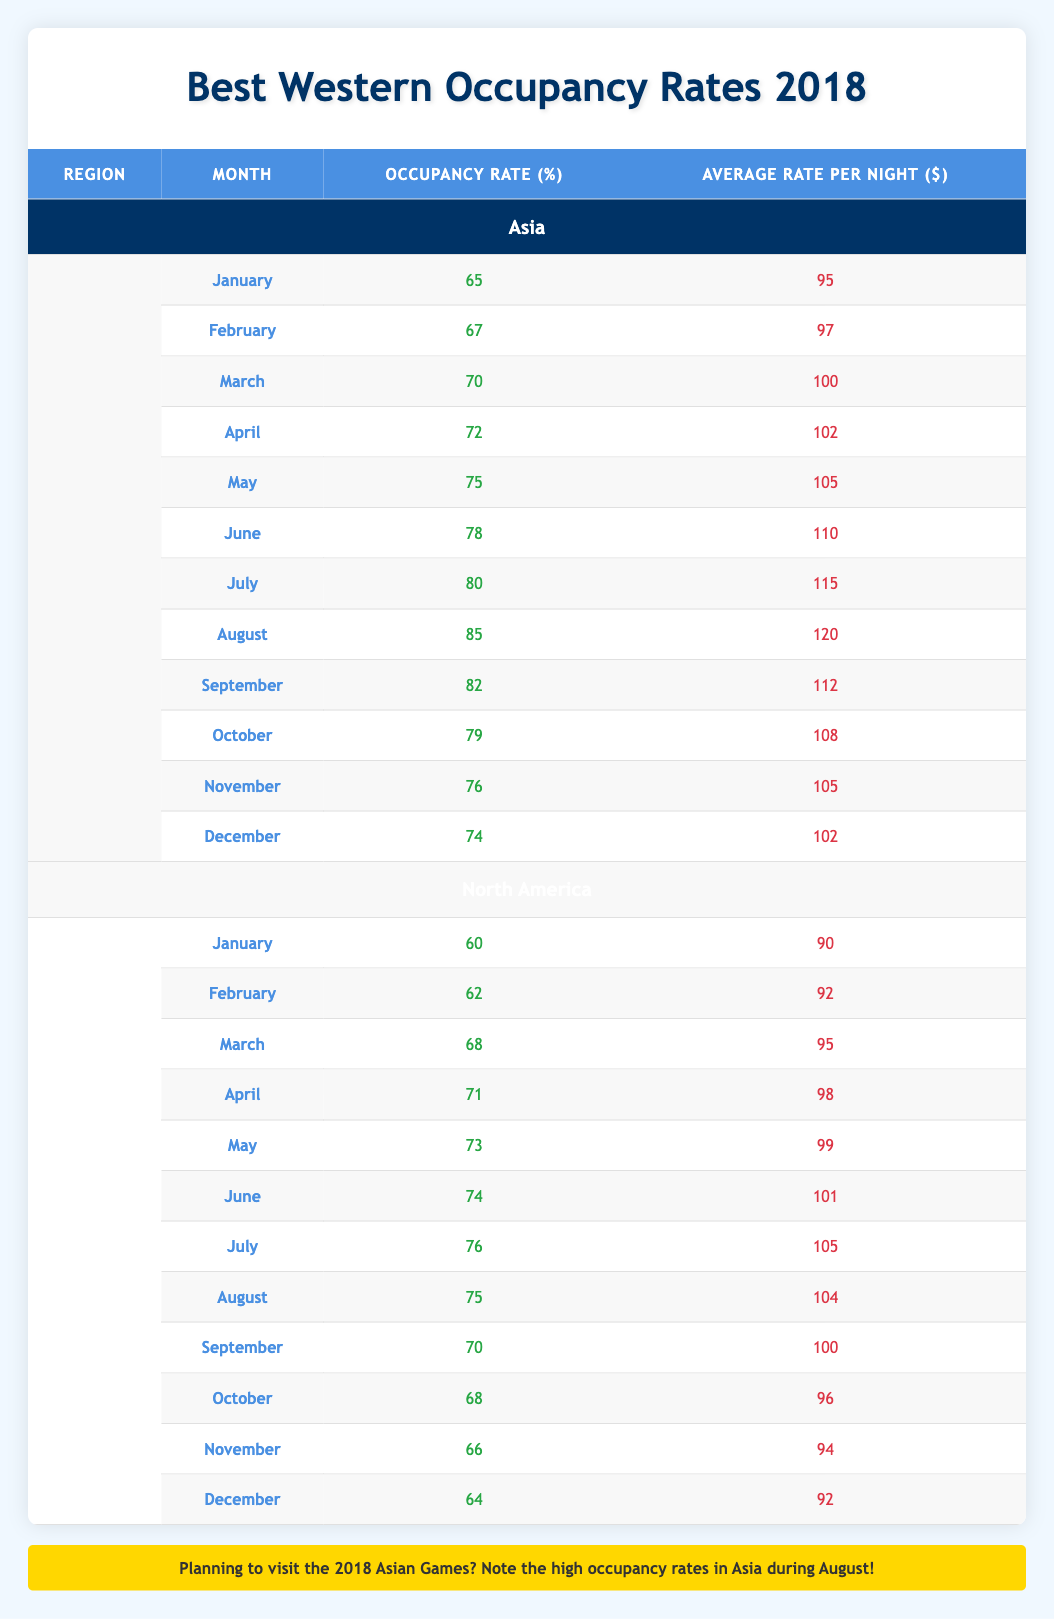What was the highest occupancy rate in Asia during 2018? The table shows monthly occupancy rates for Asia in each month of 2018. Scanning through these rates, August has the highest occupancy rate listed at 85%.
Answer: 85 What was the average occupancy rate for North America in the first half of 2018? The occupancy rates for North America from January to June are (60, 62, 68, 71, 73, 74). To find the average, add these values: 60 + 62 + 68 + 71 + 73 + 74 = 408. Then divide by 6 (the number of months): 408 / 6 = 68.
Answer: 68 Did North America have a higher occupancy rate than Asia in March 2018? The occupancy rate for Asia in March is 70, while for North America it is 68. Since 70 is greater than 68, the answer is yes.
Answer: Yes What was the difference in average rates per night between the highest month in Asia and the highest month in North America? In Asia, the highest average rate per night is 120 in August, and in North America, it is 105 in July. The difference is: 120 - 105 = 15.
Answer: 15 What was the occupancy rate trend in Asia from January to August 2018? The occupancy rates for Asia from January to August are: 65, 67, 70, 72, 75, 78, 80, and 85. Observing these values, there is an increasing trend each month leading up to August, where the highest occupancy rate occurs.
Answer: Increasing trend Which month had the lowest average rate per night in North America? The table indicates North America's average rates per night for each month. Scanning these values, January has the lowest average rate at 90.
Answer: 90 Was the overall occupancy rate higher in Asia or North America during the month of July 2018? In July 2018, Asia's occupancy rate is 80, while North America's is 76. Since 80 is greater than 76, Asia had a higher occupancy rate in July.
Answer: Asia Considering the entire year of 2018, how much did the occupancy rate increase in Asia from January to December? The occupancy rate in January for Asia is 65 and in December it is 74. The increase can be calculated as: 74 - 65 = 9.
Answer: 9 What was the average rate per night for Asia from March to May 2018? The average rates per night for Asia from March to May are 100, 105, and 110 respectively. Adding these, we get: 100 + 105 + 110 = 315. Dividing by 3 gives: 315 / 3 = 105.
Answer: 105 